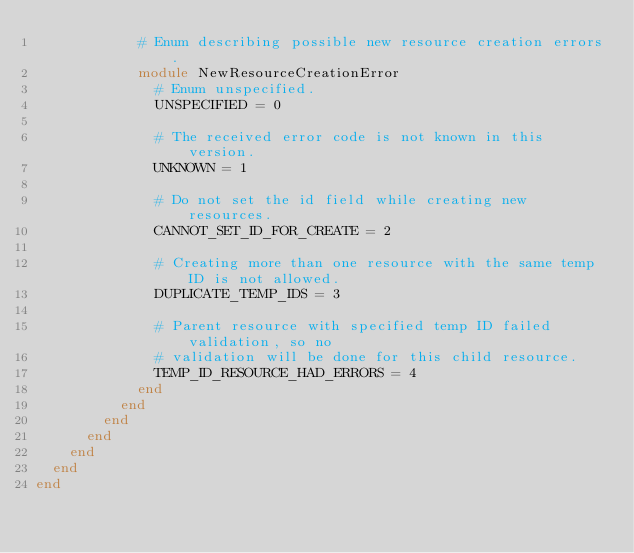Convert code to text. <code><loc_0><loc_0><loc_500><loc_500><_Ruby_>            # Enum describing possible new resource creation errors.
            module NewResourceCreationError
              # Enum unspecified.
              UNSPECIFIED = 0

              # The received error code is not known in this version.
              UNKNOWN = 1

              # Do not set the id field while creating new resources.
              CANNOT_SET_ID_FOR_CREATE = 2

              # Creating more than one resource with the same temp ID is not allowed.
              DUPLICATE_TEMP_IDS = 3

              # Parent resource with specified temp ID failed validation, so no
              # validation will be done for this child resource.
              TEMP_ID_RESOURCE_HAD_ERRORS = 4
            end
          end
        end
      end
    end
  end
end
</code> 